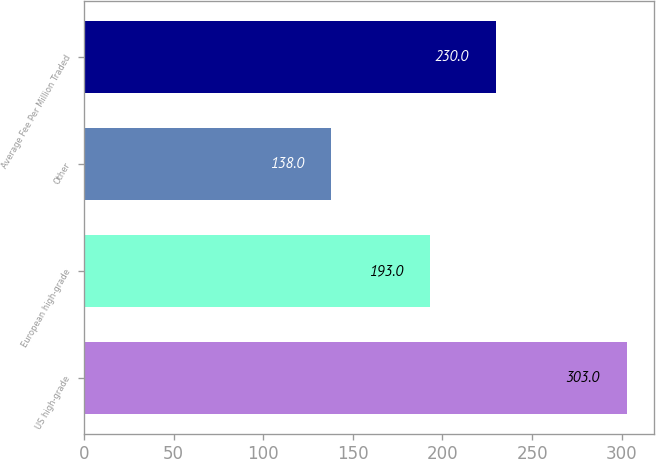<chart> <loc_0><loc_0><loc_500><loc_500><bar_chart><fcel>US high-grade<fcel>European high-grade<fcel>Other<fcel>Average Fee Per Million Traded<nl><fcel>303<fcel>193<fcel>138<fcel>230<nl></chart> 